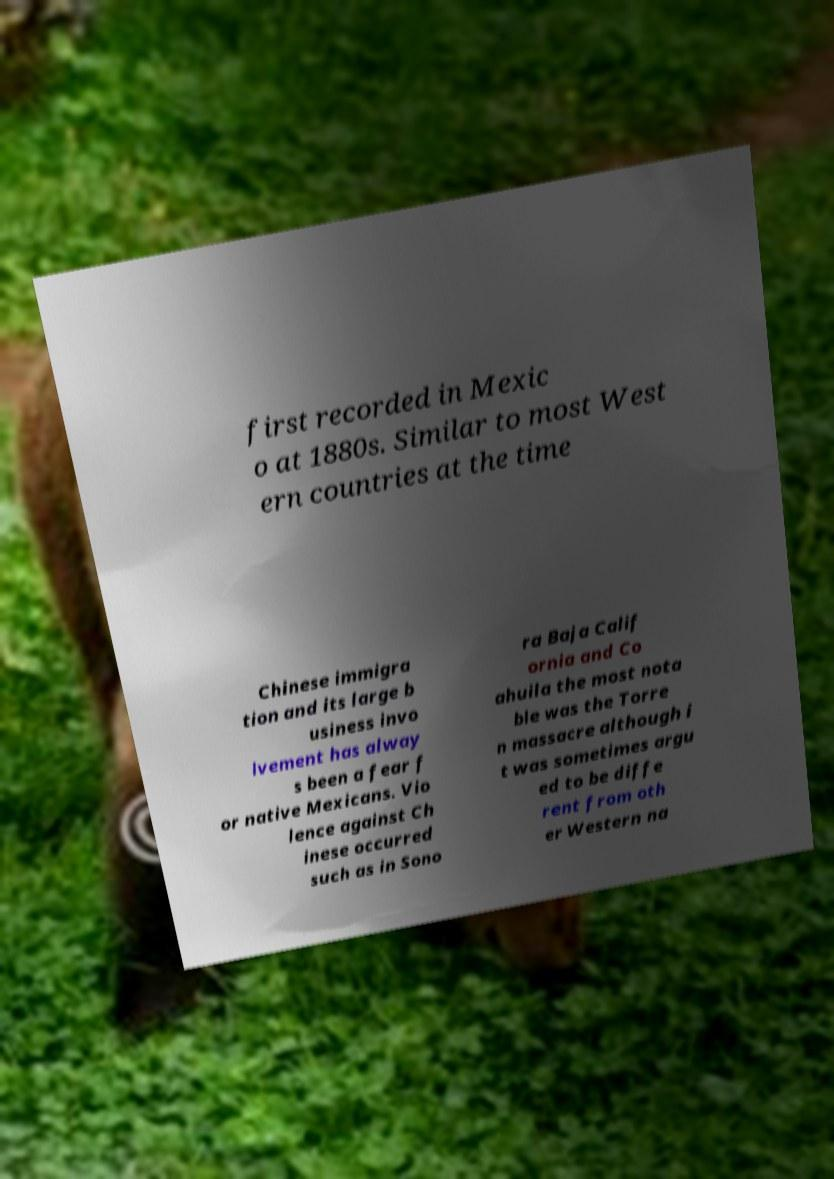There's text embedded in this image that I need extracted. Can you transcribe it verbatim? first recorded in Mexic o at 1880s. Similar to most West ern countries at the time Chinese immigra tion and its large b usiness invo lvement has alway s been a fear f or native Mexicans. Vio lence against Ch inese occurred such as in Sono ra Baja Calif ornia and Co ahuila the most nota ble was the Torre n massacre although i t was sometimes argu ed to be diffe rent from oth er Western na 